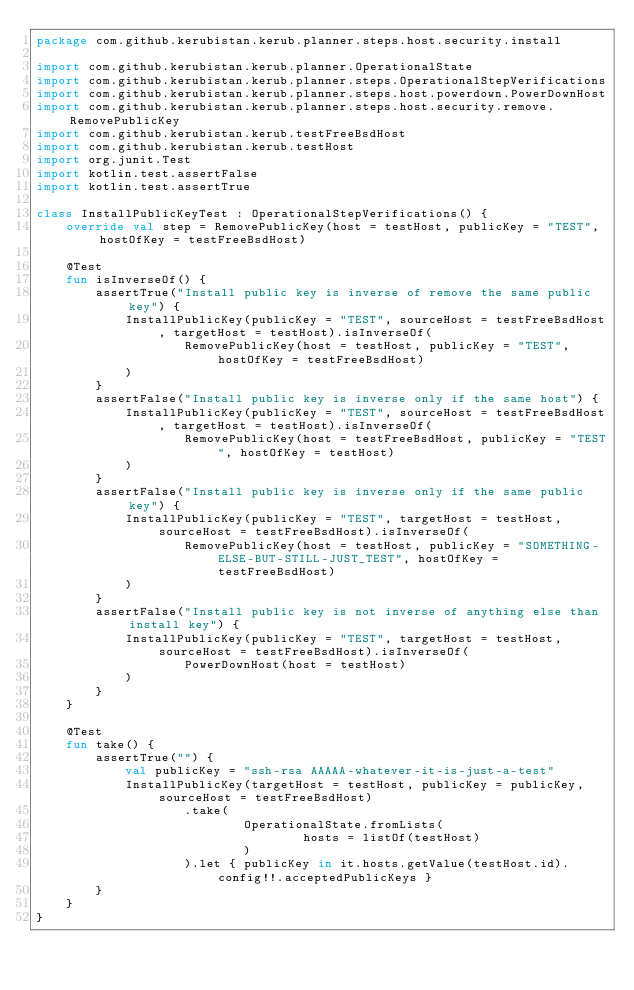<code> <loc_0><loc_0><loc_500><loc_500><_Kotlin_>package com.github.kerubistan.kerub.planner.steps.host.security.install

import com.github.kerubistan.kerub.planner.OperationalState
import com.github.kerubistan.kerub.planner.steps.OperationalStepVerifications
import com.github.kerubistan.kerub.planner.steps.host.powerdown.PowerDownHost
import com.github.kerubistan.kerub.planner.steps.host.security.remove.RemovePublicKey
import com.github.kerubistan.kerub.testFreeBsdHost
import com.github.kerubistan.kerub.testHost
import org.junit.Test
import kotlin.test.assertFalse
import kotlin.test.assertTrue

class InstallPublicKeyTest : OperationalStepVerifications() {
	override val step = RemovePublicKey(host = testHost, publicKey = "TEST", hostOfKey = testFreeBsdHost)

	@Test
	fun isInverseOf() {
		assertTrue("Install public key is inverse of remove the same public key") {
			InstallPublicKey(publicKey = "TEST", sourceHost = testFreeBsdHost, targetHost = testHost).isInverseOf(
					RemovePublicKey(host = testHost, publicKey = "TEST", hostOfKey = testFreeBsdHost)
			)
		}
		assertFalse("Install public key is inverse only if the same host") {
			InstallPublicKey(publicKey = "TEST", sourceHost = testFreeBsdHost, targetHost = testHost).isInverseOf(
					RemovePublicKey(host = testFreeBsdHost, publicKey = "TEST", hostOfKey = testHost)
			)
		}
		assertFalse("Install public key is inverse only if the same public key") {
			InstallPublicKey(publicKey = "TEST", targetHost = testHost, sourceHost = testFreeBsdHost).isInverseOf(
					RemovePublicKey(host = testHost, publicKey = "SOMETHING-ELSE-BUT-STILL-JUST_TEST", hostOfKey = testFreeBsdHost)
			)
		}
		assertFalse("Install public key is not inverse of anything else than install key") {
			InstallPublicKey(publicKey = "TEST", targetHost = testHost, sourceHost = testFreeBsdHost).isInverseOf(
					PowerDownHost(host = testHost)
			)
		}
	}

	@Test
	fun take() {
		assertTrue("") {
			val publicKey = "ssh-rsa AAAAA-whatever-it-is-just-a-test"
			InstallPublicKey(targetHost = testHost, publicKey = publicKey, sourceHost = testFreeBsdHost)
					.take(
							OperationalState.fromLists(
									hosts = listOf(testHost)
							)
					).let { publicKey in it.hosts.getValue(testHost.id).config!!.acceptedPublicKeys }
		}
	}
}</code> 